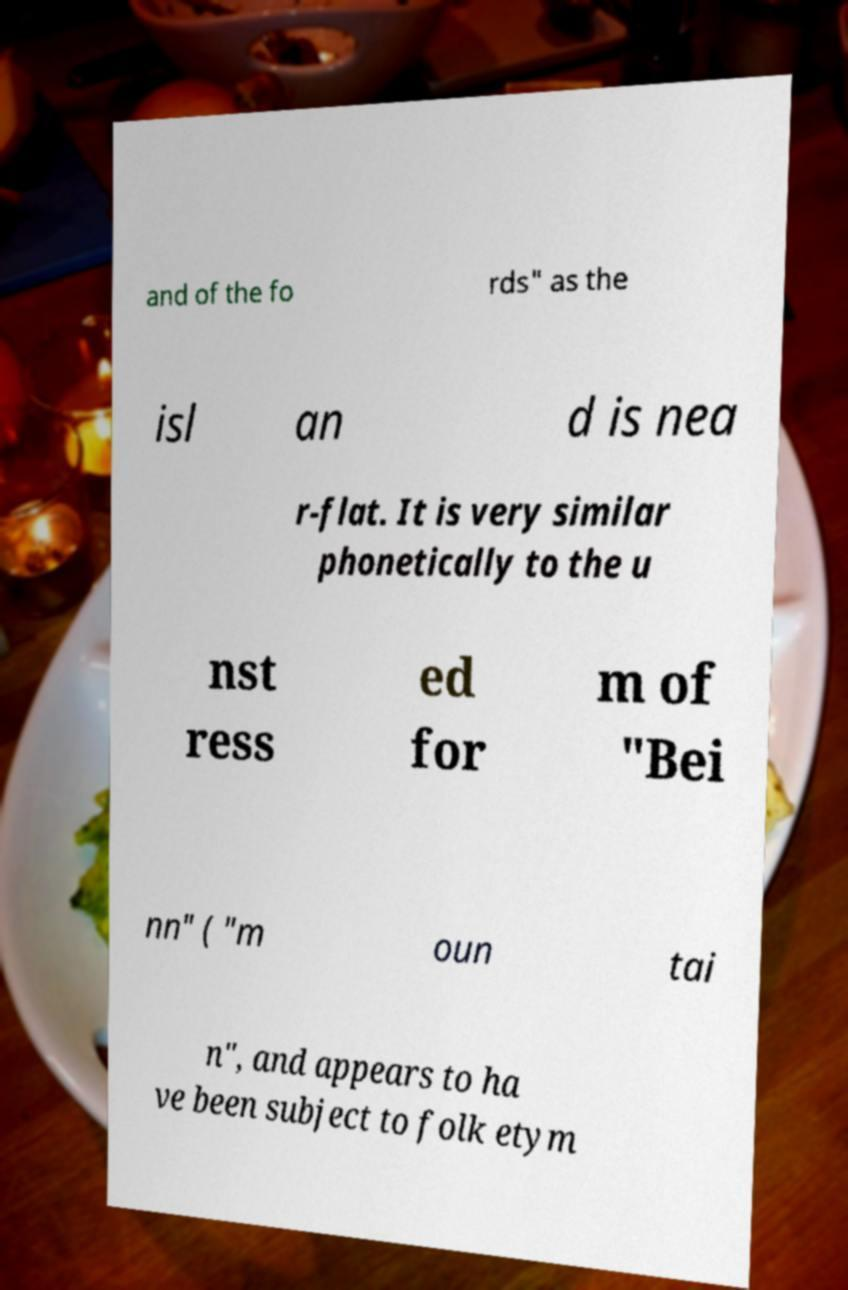I need the written content from this picture converted into text. Can you do that? and of the fo rds" as the isl an d is nea r-flat. It is very similar phonetically to the u nst ress ed for m of "Bei nn" ( "m oun tai n", and appears to ha ve been subject to folk etym 